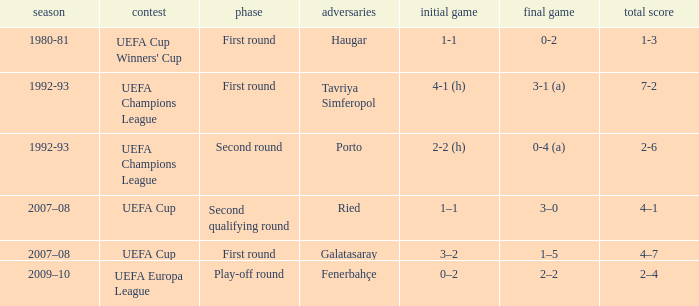What is the total number of 2nd leg where aggregate is 7-2 1.0. 